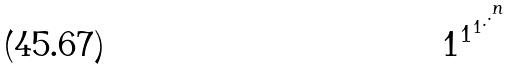Convert formula to latex. <formula><loc_0><loc_0><loc_500><loc_500>1 ^ { 1 ^ { 1 ^ { . ^ { . ^ { n } } } } }</formula> 